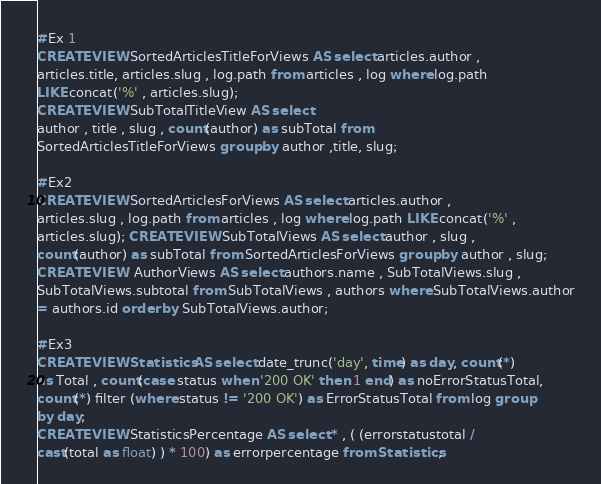<code> <loc_0><loc_0><loc_500><loc_500><_SQL_>#Ex 1 
CREATE VIEW SortedArticlesTitleForViews AS select articles.author ,
articles.title, articles.slug , log.path from articles , log where log.path
LIKE concat('%' , articles.slug); 
CREATE VIEW SubTotalTitleView AS select
author , title , slug , count(author) as subTotal from
SortedArticlesTitleForViews group by author ,title, slug;

#Ex2 
CREATE VIEW SortedArticlesForViews AS select articles.author ,
articles.slug , log.path from articles , log where log.path LIKE concat('%' ,
articles.slug); CREATE VIEW SubTotalViews AS select author , slug ,
count(author) as subTotal from SortedArticlesForViews group by author , slug;
CREATE VIEW  AuthorViews AS select authors.name , SubTotalViews.slug ,
SubTotalViews.subtotal from SubTotalViews , authors where SubTotalViews.author
= authors.id order by SubTotalViews.author;

#Ex3 
CREATE VIEW Statistics AS select date_trunc('day', time) as day, count(*)
as Total , count(case status when '200 OK' then 1 end) as noErrorStatusTotal,
count(*) filter (where status != '200 OK') as ErrorStatusTotal from log group
by day; 
CREATE VIEW StatisticsPercentage AS select * , ( (errorstatustotal /
cast(total as float) ) * 100) as errorpercentage from Statistics;
</code> 